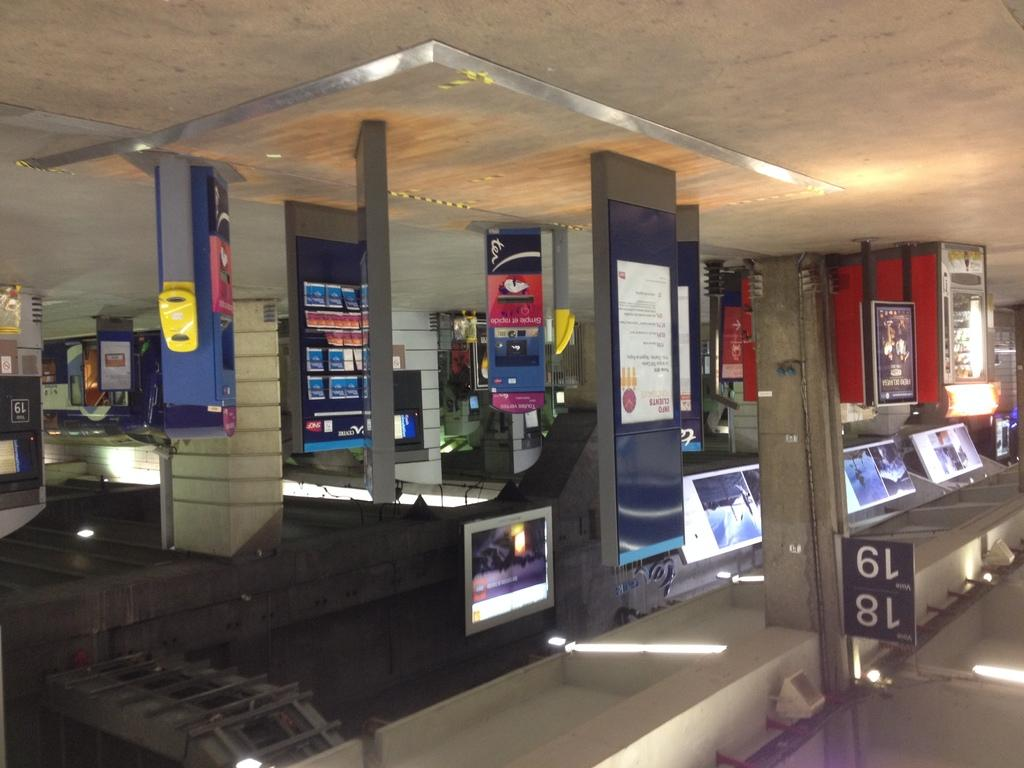<image>
Describe the image concisely. An upside down picture with a banner with the numbers 18 and 19. 